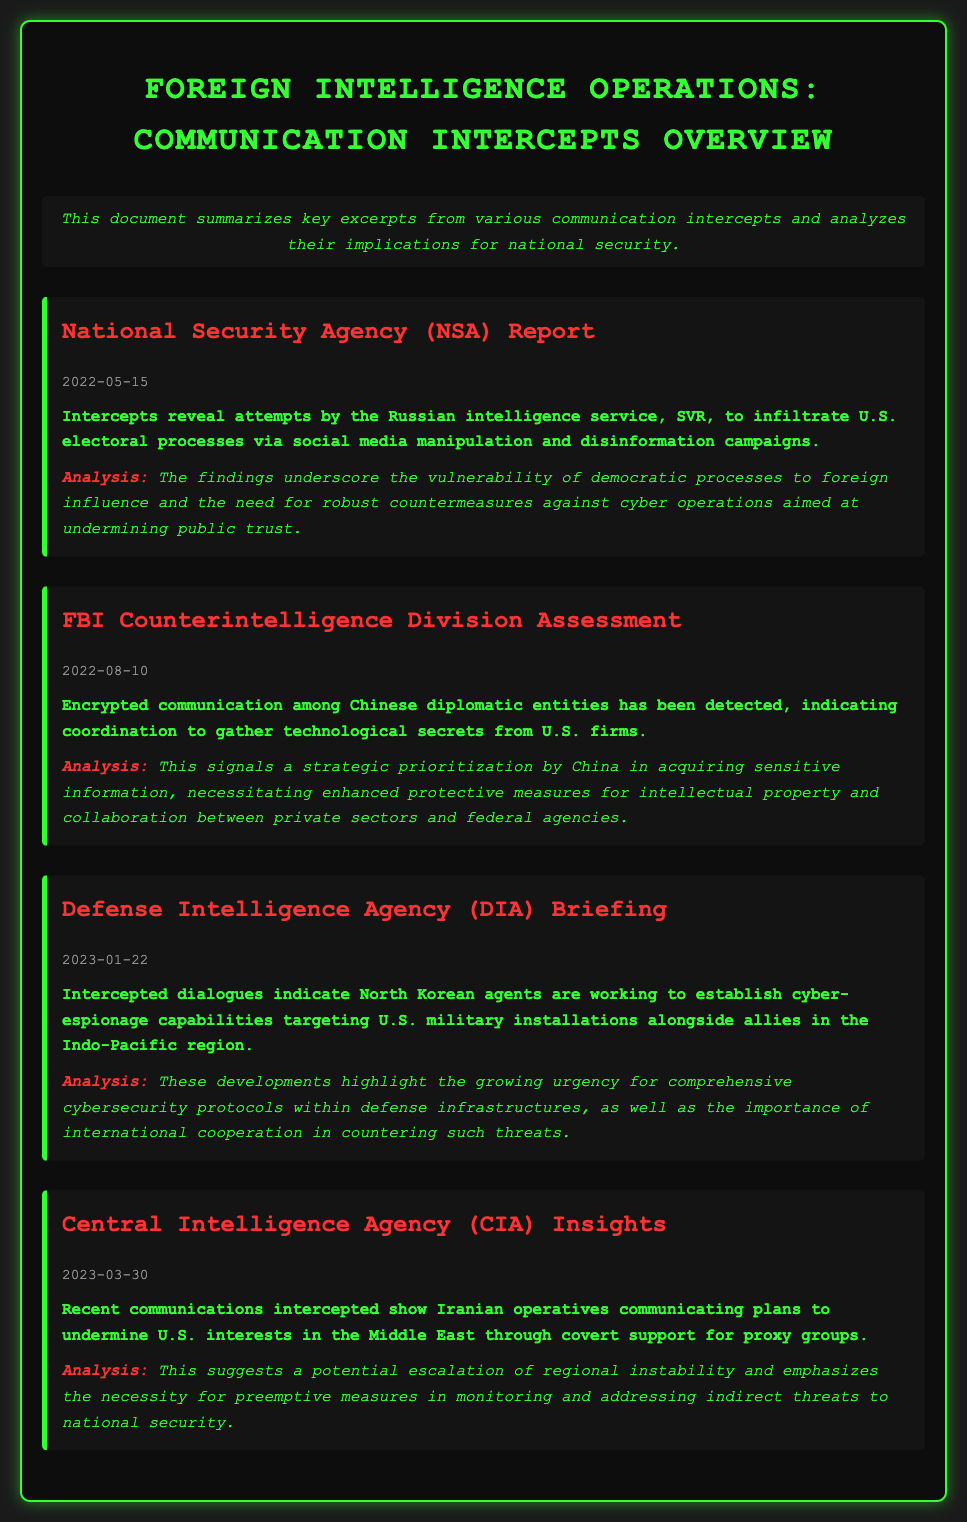What is the date of the NSA report? The date provided for the NSA report in the document is "2022-05-15".
Answer: 2022-05-15 What foreign intelligence service is mentioned in relation to social media manipulation? The Russian intelligence service, SVR, is mentioned regarding social media manipulation and disinformation campaigns.
Answer: SVR What type of communication was detected among Chinese diplomatic entities? The document states that "encrypted communication" was detected among Chinese diplomatic entities.
Answer: Encrypted communication What is the primary concern highlighted by the DIA Briefing? The primary concern highlighted by the DIA Briefing involves "comprehensive cybersecurity protocols within defense infrastructures".
Answer: Comprehensive cybersecurity protocols Which country is indicated to be establishing cyber-espionage capabilities? North Korea is indicated as working to establish cyber-espionage capabilities targeting U.S. military installations.
Answer: North Korea What is the implication of Iranian operatives' communications? The implication is a potential "escalation of regional instability" in relation to U.S. interests in the Middle East.
Answer: Escalation of regional instability What agency provided insights on Iranian operatives? The Central Intelligence Agency (CIA) provided insights on Iranian operatives’ communications.
Answer: Central Intelligence Agency (CIA) How does the document describe China's strategic activities? The document describes it as a "strategic prioritization" in acquiring sensitive information from U.S. firms.
Answer: Strategic prioritization 